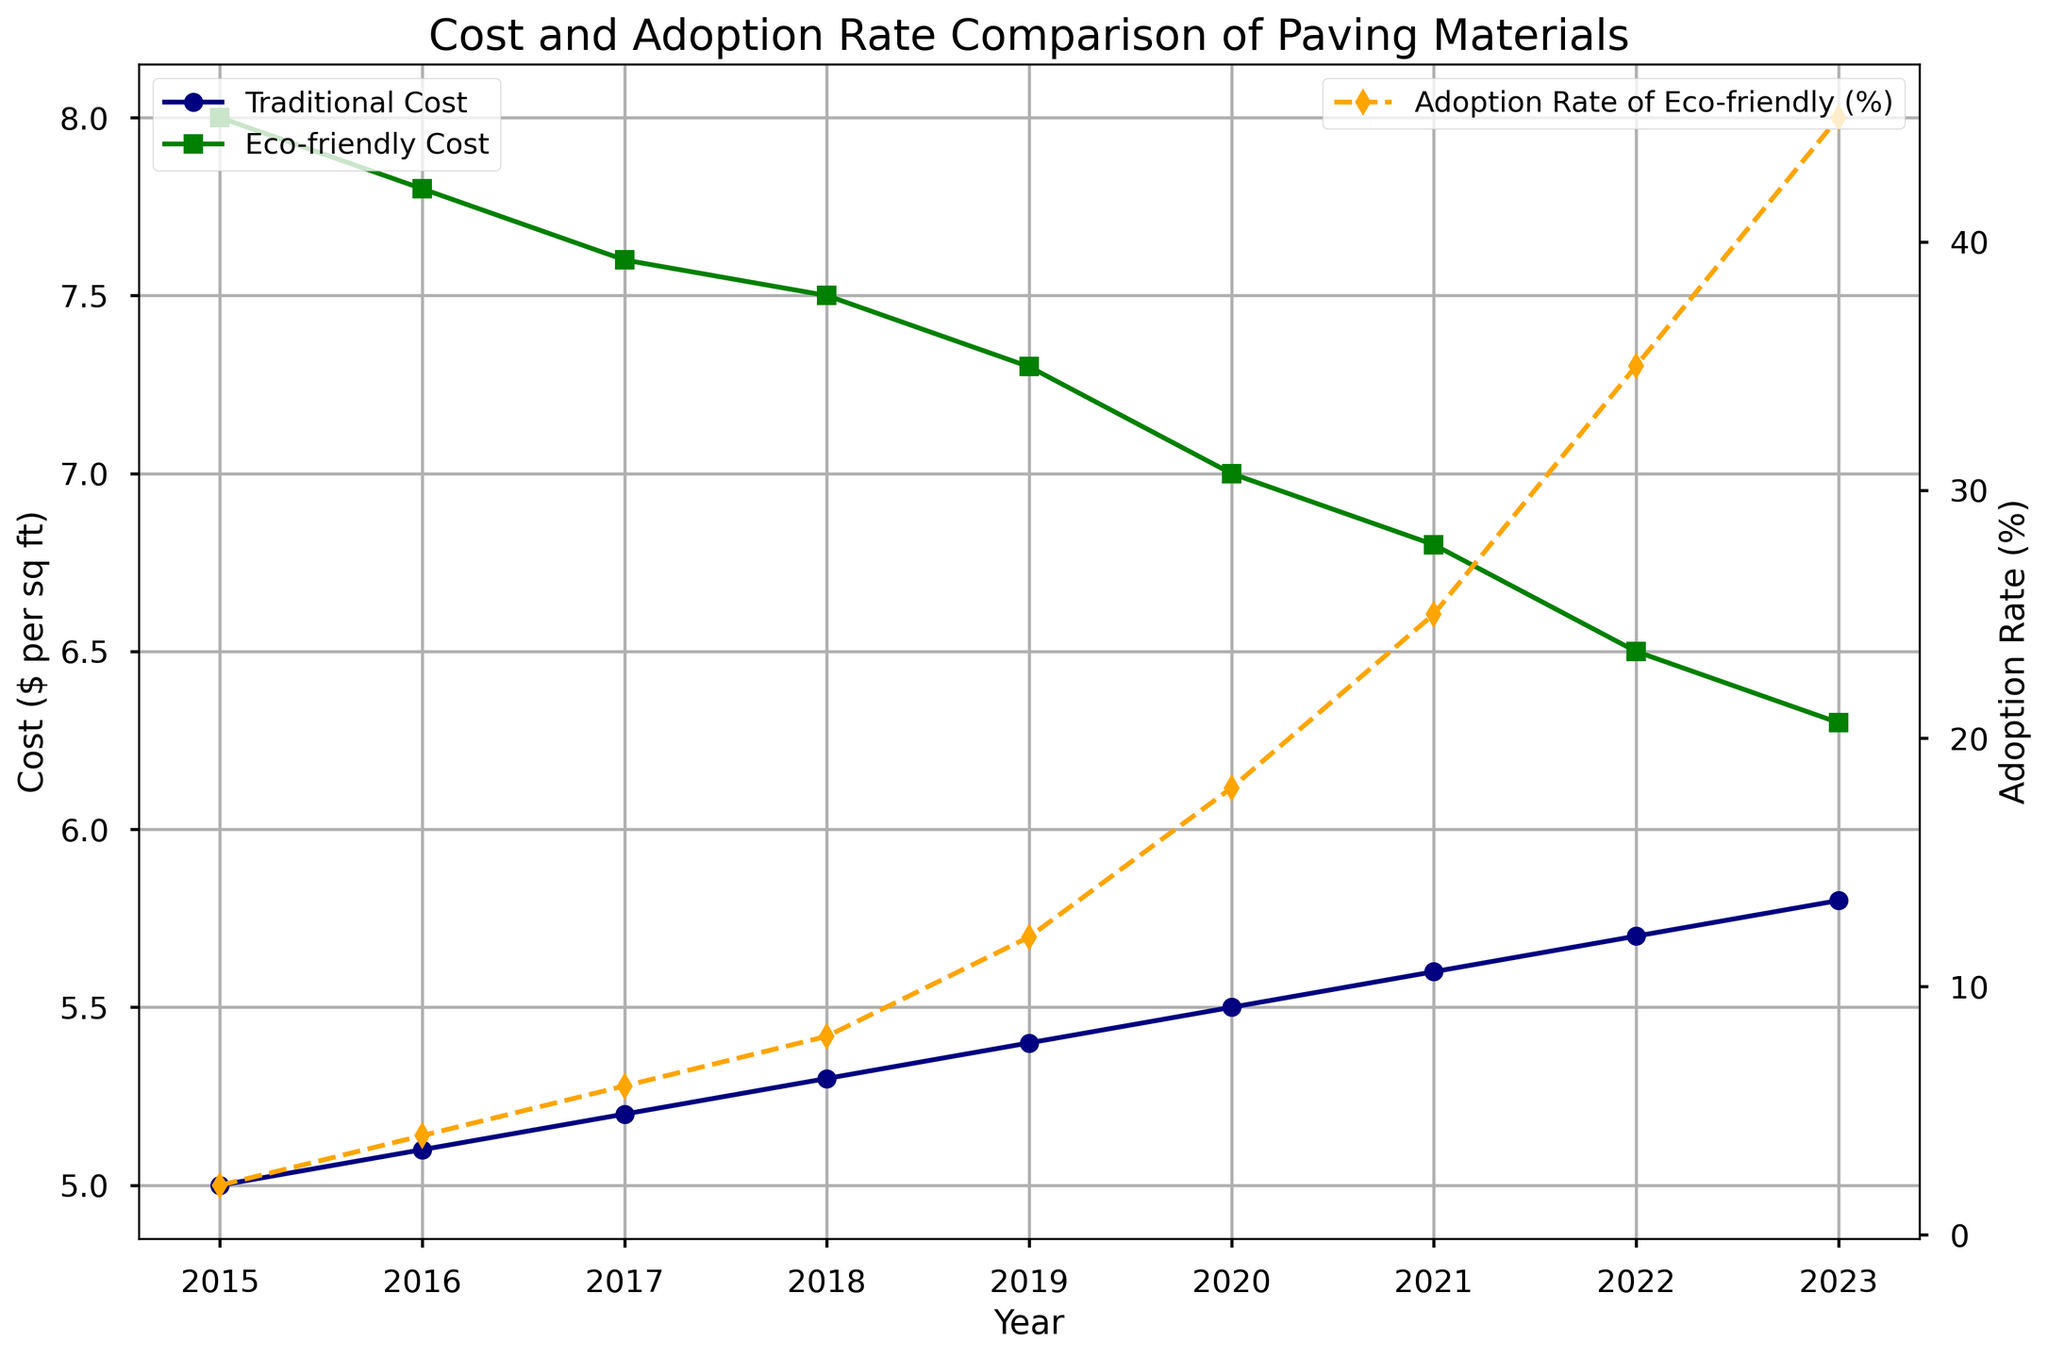What is the cost difference between traditional and eco-friendly paving materials in 2015? The traditional cost is $5 per sq ft, and the eco-friendly cost is $8 per sq ft. The difference is $8 - $5.
Answer: $3 per sq ft How much did the adoption rate of eco-friendly paving increase from 2015 to 2023? The adoption rate in 2015 was 2%, and in 2023 it is 45%. The increase is 45% - 2%.
Answer: 43% Which year had the smallest difference in cost between traditional and eco-friendly paving materials? Examine each year’s data and subtract the traditional cost from the eco-friendly cost. The smallest difference occurs in 2023, where the eco-friendly cost is $6.3 and the traditional cost is $5.8, with a difference of $0.5.
Answer: 2023 Compare the trend of traditional versus eco-friendly costs over the years. Which one decreased more significantly? Traditional costs steadily increased from $5 to $5.8 per sq ft from 2015 to 2023. Eco-friendly costs decreased from $8 to $6.3 per sq ft over the same period. Hence, eco-friendly costs decreased more significantly.
Answer: Eco-friendly paving costs What is the average annual increase in the adoption rate of eco-friendly paving materials over the period? Subtract 2015 adoption rate from 2023 adoption rate and divide by years difference: (45% - 2%) / (2023 - 2015).
Answer: 5.375% per year In which year did eco-friendly paving materials first become cheaper than $7 per sq ft? By checking the yearly data, eco-friendly costs fell below $7 in 2020.
Answer: 2020 What is the total increase in traditional paving material cost from 2016 to 2022? Subtract 2016 cost from 2022 cost: $5.7 - $5.1.
Answer: $0.6 per sq ft At what year did the adoption rate of eco-friendly paving materials reach 25%? The adoption rate was 25% in 2021 according to the chart data.
Answer: 2021 Which year shows the highest adoption rate of eco-friendly paving materials? The highest adoption rate shown in the chart data is in 2023 at 45%.
Answer: 2023 